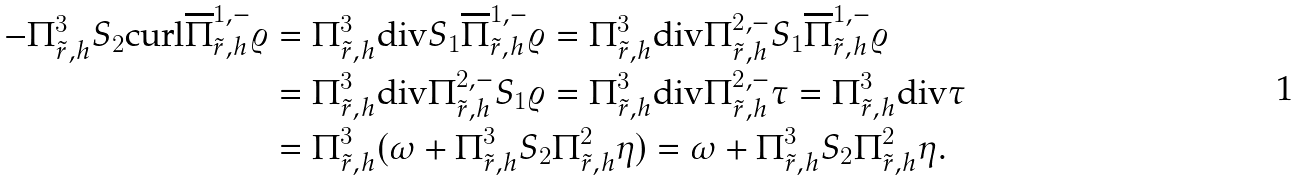<formula> <loc_0><loc_0><loc_500><loc_500>- \Pi _ { \tilde { r } , h } ^ { 3 } S _ { 2 } \text {curl} \overline { \Pi } _ { \tilde { r } , h } ^ { 1 , - } \varrho & = \Pi _ { \tilde { r } , h } ^ { 3 } \text {div} S _ { 1 } \overline { \Pi } _ { \tilde { r } , h } ^ { 1 , - } \varrho = \Pi _ { \tilde { r } , h } ^ { 3 } \text {div} \Pi _ { \tilde { r } , h } ^ { 2 , - } S _ { 1 } \overline { \Pi } _ { \tilde { r } , h } ^ { 1 , - } \varrho \\ & = \Pi _ { \tilde { r } , h } ^ { 3 } \text {div} \Pi _ { \tilde { r } , h } ^ { 2 , - } S _ { 1 } \varrho = \Pi _ { \tilde { r } , h } ^ { 3 } \text {div} \Pi _ { \tilde { r } , h } ^ { 2 , - } \tau = \Pi _ { \tilde { r } , h } ^ { 3 } \text {div} \tau \\ & = \Pi _ { \tilde { r } , h } ^ { 3 } ( \omega + \Pi _ { \tilde { r } , h } ^ { 3 } S _ { 2 } \Pi _ { \tilde { r } , h } ^ { 2 } \eta ) = \omega + \Pi _ { \tilde { r } , h } ^ { 3 } S _ { 2 } \Pi _ { \tilde { r } , h } ^ { 2 } \eta .</formula> 